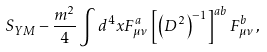Convert formula to latex. <formula><loc_0><loc_0><loc_500><loc_500>S _ { Y M } - \frac { m ^ { 2 } } { 4 } \int d ^ { 4 } x F _ { \mu \nu } ^ { a } \left [ \left ( D ^ { 2 } \right ) ^ { - 1 } \right ] ^ { a b } F _ { \mu \nu } ^ { b } \, ,</formula> 